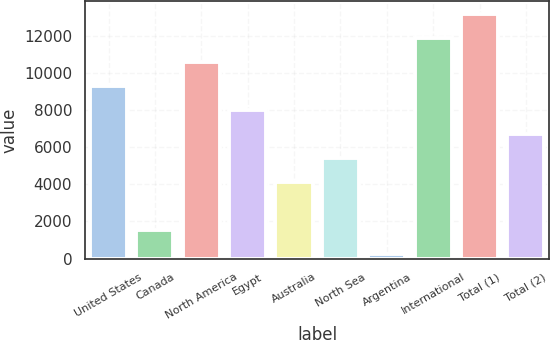Convert chart to OTSL. <chart><loc_0><loc_0><loc_500><loc_500><bar_chart><fcel>United States<fcel>Canada<fcel>North America<fcel>Egypt<fcel>Australia<fcel>North Sea<fcel>Argentina<fcel>International<fcel>Total (1)<fcel>Total (2)<nl><fcel>9328.3<fcel>1564.9<fcel>10622.2<fcel>8034.4<fcel>4152.7<fcel>5446.6<fcel>271<fcel>11916.1<fcel>13210<fcel>6740.5<nl></chart> 